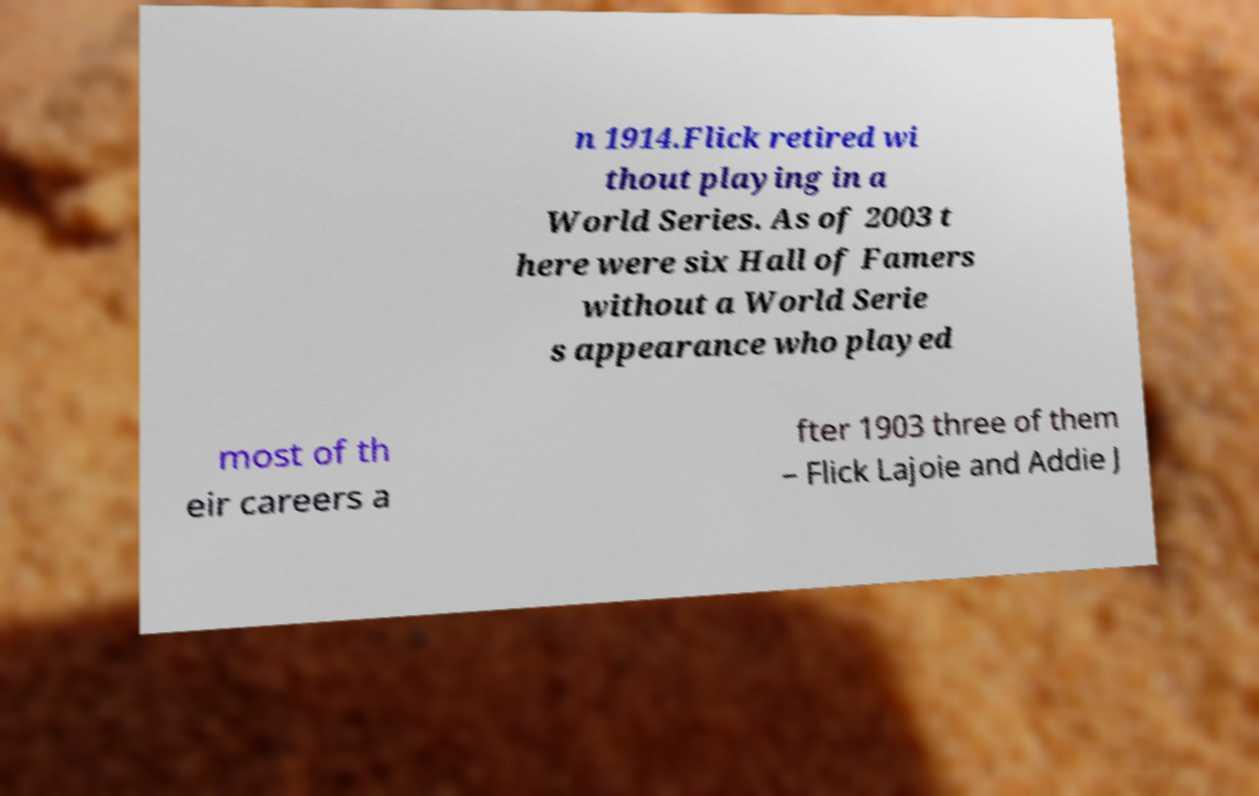For documentation purposes, I need the text within this image transcribed. Could you provide that? n 1914.Flick retired wi thout playing in a World Series. As of 2003 t here were six Hall of Famers without a World Serie s appearance who played most of th eir careers a fter 1903 three of them – Flick Lajoie and Addie J 